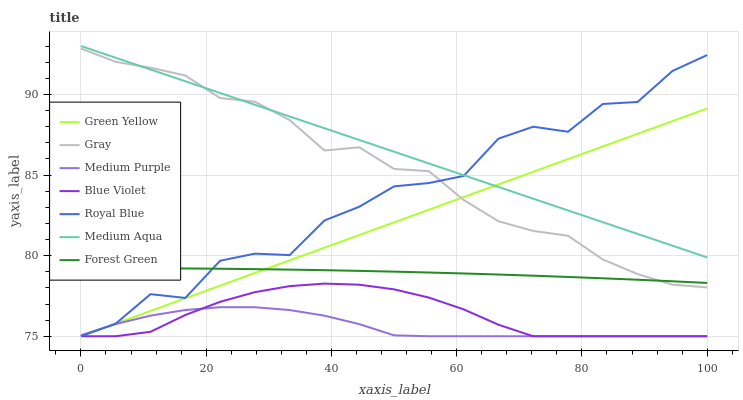Does Royal Blue have the minimum area under the curve?
Answer yes or no. No. Does Royal Blue have the maximum area under the curve?
Answer yes or no. No. Is Medium Purple the smoothest?
Answer yes or no. No. Is Medium Purple the roughest?
Answer yes or no. No. Does Forest Green have the lowest value?
Answer yes or no. No. Does Royal Blue have the highest value?
Answer yes or no. No. Is Forest Green less than Medium Aqua?
Answer yes or no. Yes. Is Medium Aqua greater than Forest Green?
Answer yes or no. Yes. Does Forest Green intersect Medium Aqua?
Answer yes or no. No. 